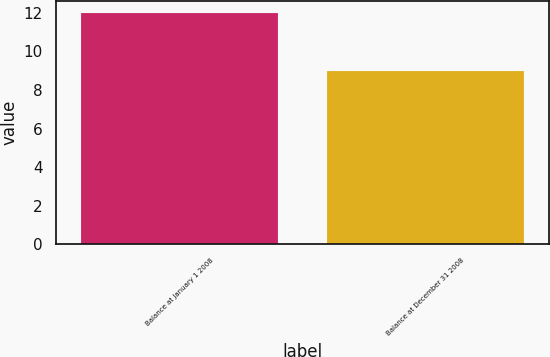Convert chart. <chart><loc_0><loc_0><loc_500><loc_500><bar_chart><fcel>Balance at January 1 2008<fcel>Balance at December 31 2008<nl><fcel>12<fcel>9<nl></chart> 